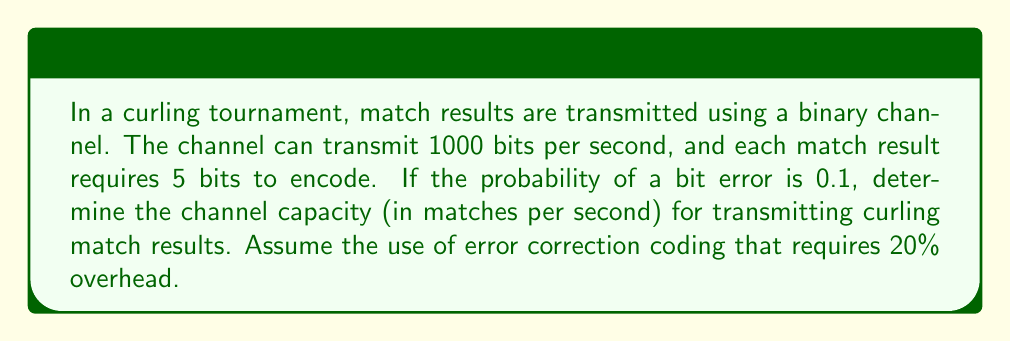Can you answer this question? To solve this problem, we'll follow these steps:

1. Calculate the raw bit rate of the channel
2. Determine the effective bit rate after error correction coding
3. Calculate the number of bits required per match result
4. Compute the channel capacity in matches per second

Step 1: Raw bit rate
The raw bit rate is given as 1000 bits per second.

Step 2: Effective bit rate after error correction coding
The error correction coding requires 20% overhead, which means only 80% of the bits are used for actual data. We can calculate the effective bit rate as:

$$ \text{Effective bit rate} = 1000 \times 0.8 = 800 \text{ bits per second} $$

Step 3: Bits required per match result
Each match result requires 5 bits to encode. However, we need to account for the error correction overhead:

$$ \text{Bits per match} = 5 \times \frac{1}{0.8} = 6.25 \text{ bits} $$

Step 4: Channel capacity in matches per second
To calculate the channel capacity, we divide the effective bit rate by the number of bits required per match:

$$ \text{Channel capacity} = \frac{800 \text{ bits/s}}{6.25 \text{ bits/match}} = 128 \text{ matches per second} $$

It's worth noting that this calculation doesn't take into account the bit error probability of 0.1. In practice, this high error rate would significantly reduce the effective channel capacity. However, we assume that the error correction coding is sufficient to handle these errors.
Answer: The channel capacity for transmitting curling match results is 128 matches per second. 